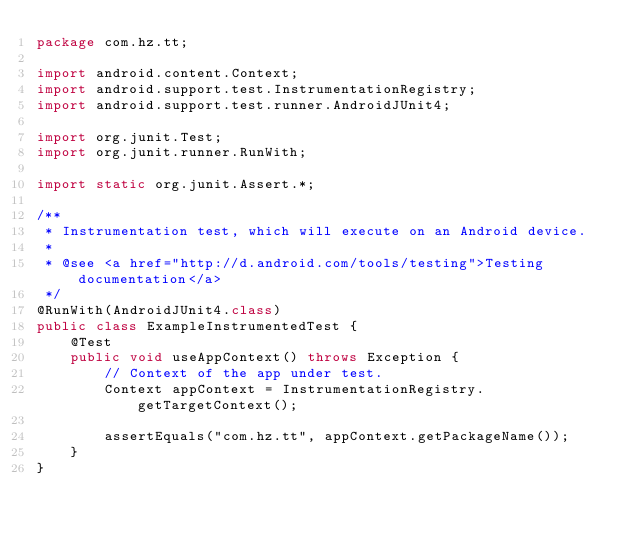Convert code to text. <code><loc_0><loc_0><loc_500><loc_500><_Java_>package com.hz.tt;

import android.content.Context;
import android.support.test.InstrumentationRegistry;
import android.support.test.runner.AndroidJUnit4;

import org.junit.Test;
import org.junit.runner.RunWith;

import static org.junit.Assert.*;

/**
 * Instrumentation test, which will execute on an Android device.
 *
 * @see <a href="http://d.android.com/tools/testing">Testing documentation</a>
 */
@RunWith(AndroidJUnit4.class)
public class ExampleInstrumentedTest {
    @Test
    public void useAppContext() throws Exception {
        // Context of the app under test.
        Context appContext = InstrumentationRegistry.getTargetContext();

        assertEquals("com.hz.tt", appContext.getPackageName());
    }
}
</code> 